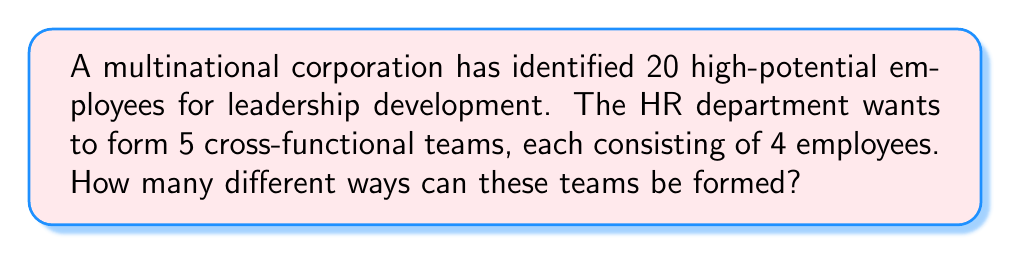Provide a solution to this math problem. To solve this problem, we need to use the concept of combinations and the multiplication principle. Let's break it down step-by-step:

1) First, we need to choose 4 employees for the first team. This can be done in $\binom{20}{4}$ ways.

2) After forming the first team, we have 16 employees left and need to choose 4 for the second team. This can be done in $\binom{16}{4}$ ways.

3) Following the same logic, we have:
   - $\binom{12}{4}$ ways for the third team
   - $\binom{8}{4}$ ways for the fourth team
   - $\binom{4}{4}$ way for the fifth team

4) By the multiplication principle, the total number of ways to form these teams is:

   $$\binom{20}{4} \cdot \binom{16}{4} \cdot \binom{12}{4} \cdot \binom{8}{4} \cdot \binom{4}{4}$$

5) Let's calculate each combination:
   
   $\binom{20}{4} = 4845$
   $\binom{16}{4} = 1820$
   $\binom{12}{4} = 495$
   $\binom{8}{4} = 70$
   $\binom{4}{4} = 1$

6) Multiplying these numbers:

   $4845 \cdot 1820 \cdot 495 \cdot 70 \cdot 1 = 3,066,227,400,000$

However, this counts each arrangement multiple times because the order of selecting the teams doesn't matter. We need to divide by the number of ways to arrange 5 teams, which is 5! = 120.

Therefore, the final answer is:

$$\frac{3,066,227,400,000}{120} = 25,551,895,000$$
Answer: 25,551,895,000 